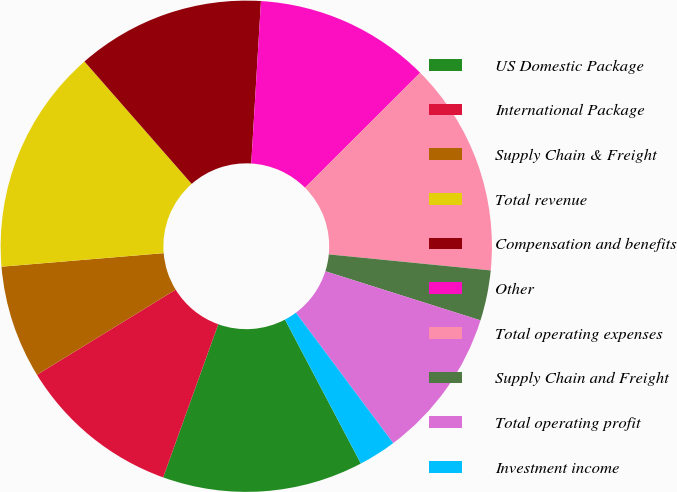Convert chart. <chart><loc_0><loc_0><loc_500><loc_500><pie_chart><fcel>US Domestic Package<fcel>International Package<fcel>Supply Chain & Freight<fcel>Total revenue<fcel>Compensation and benefits<fcel>Other<fcel>Total operating expenses<fcel>Supply Chain and Freight<fcel>Total operating profit<fcel>Investment income<nl><fcel>13.22%<fcel>10.74%<fcel>7.44%<fcel>14.88%<fcel>12.4%<fcel>11.57%<fcel>14.05%<fcel>3.31%<fcel>9.92%<fcel>2.48%<nl></chart> 